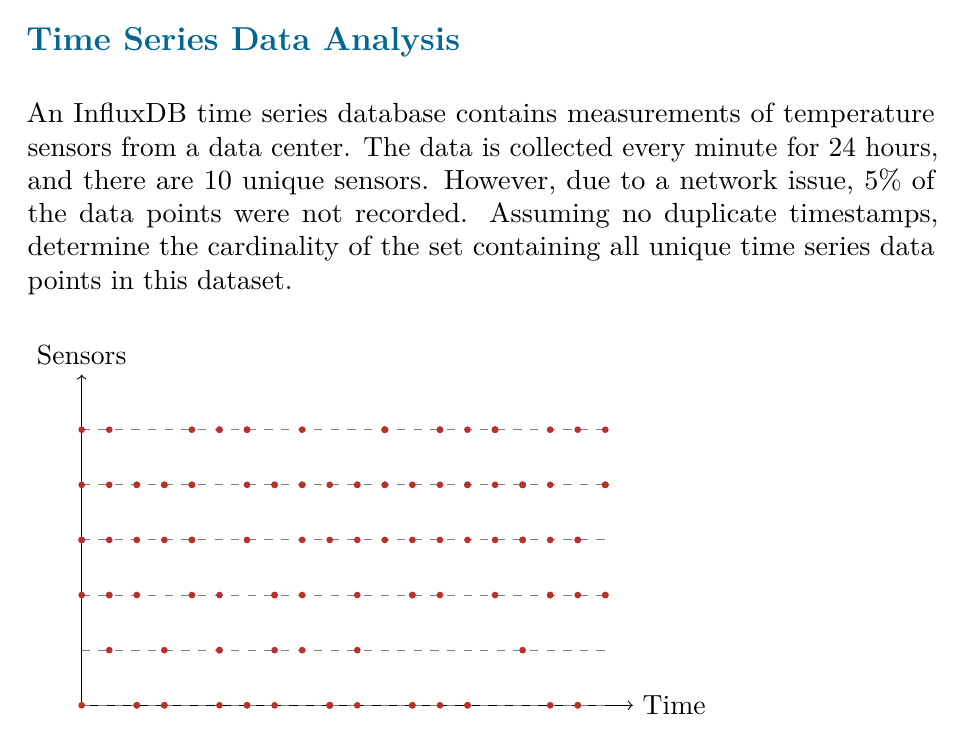Give your solution to this math problem. Let's approach this step-by-step:

1) First, let's calculate the total number of data points if there were no missing data:
   - 24 hours = 1440 minutes (24 * 60)
   - 10 sensors
   - Total data points = $1440 * 10 = 14400$

2) Now, we need to account for the 5% of missing data:
   - Missing data points = $5\% \text{ of } 14400 = 0.05 * 14400 = 720$

3) Therefore, the number of actual data points collected is:
   $14400 - 720 = 13680$

4) In set theory, the cardinality of a set is the number of unique elements in the set. Since we're assuming no duplicate timestamps and each sensor provides a unique measurement, each data point in our set is unique.

5) Thus, the cardinality of the set is equal to the number of actual data points collected.
Answer: $13680$ 